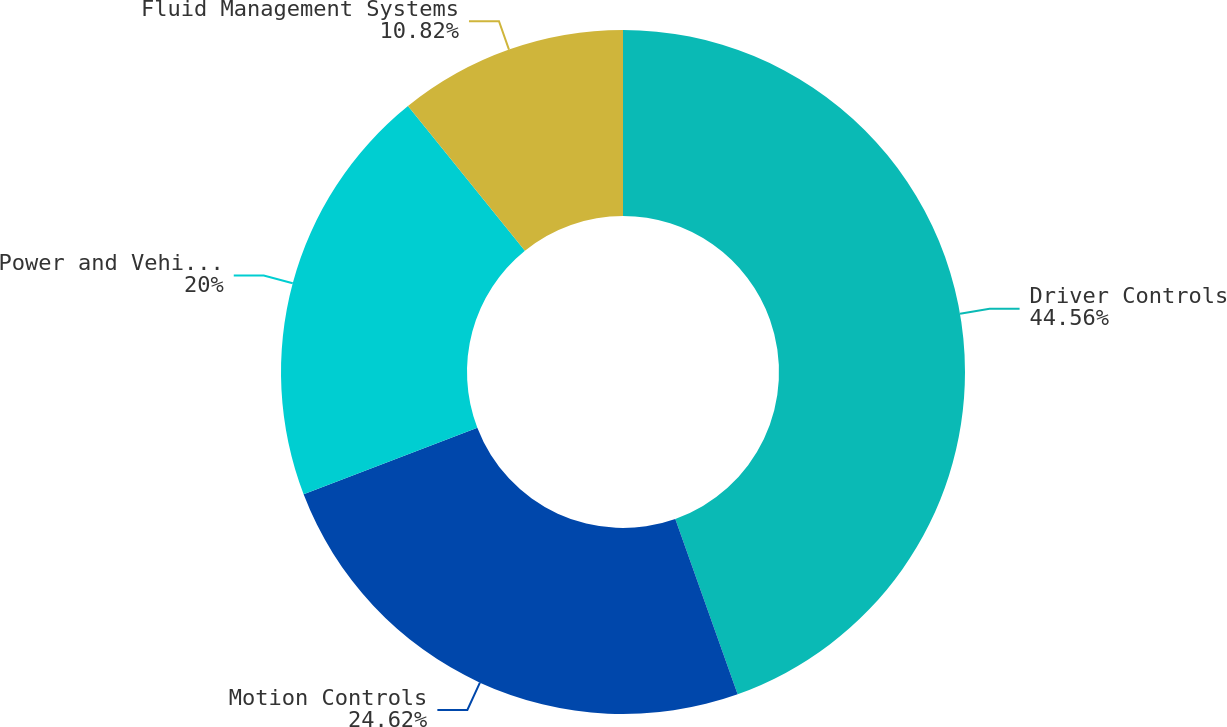Convert chart. <chart><loc_0><loc_0><loc_500><loc_500><pie_chart><fcel>Driver Controls<fcel>Motion Controls<fcel>Power and Vehicle Management<fcel>Fluid Management Systems<nl><fcel>44.56%<fcel>24.62%<fcel>20.0%<fcel>10.82%<nl></chart> 